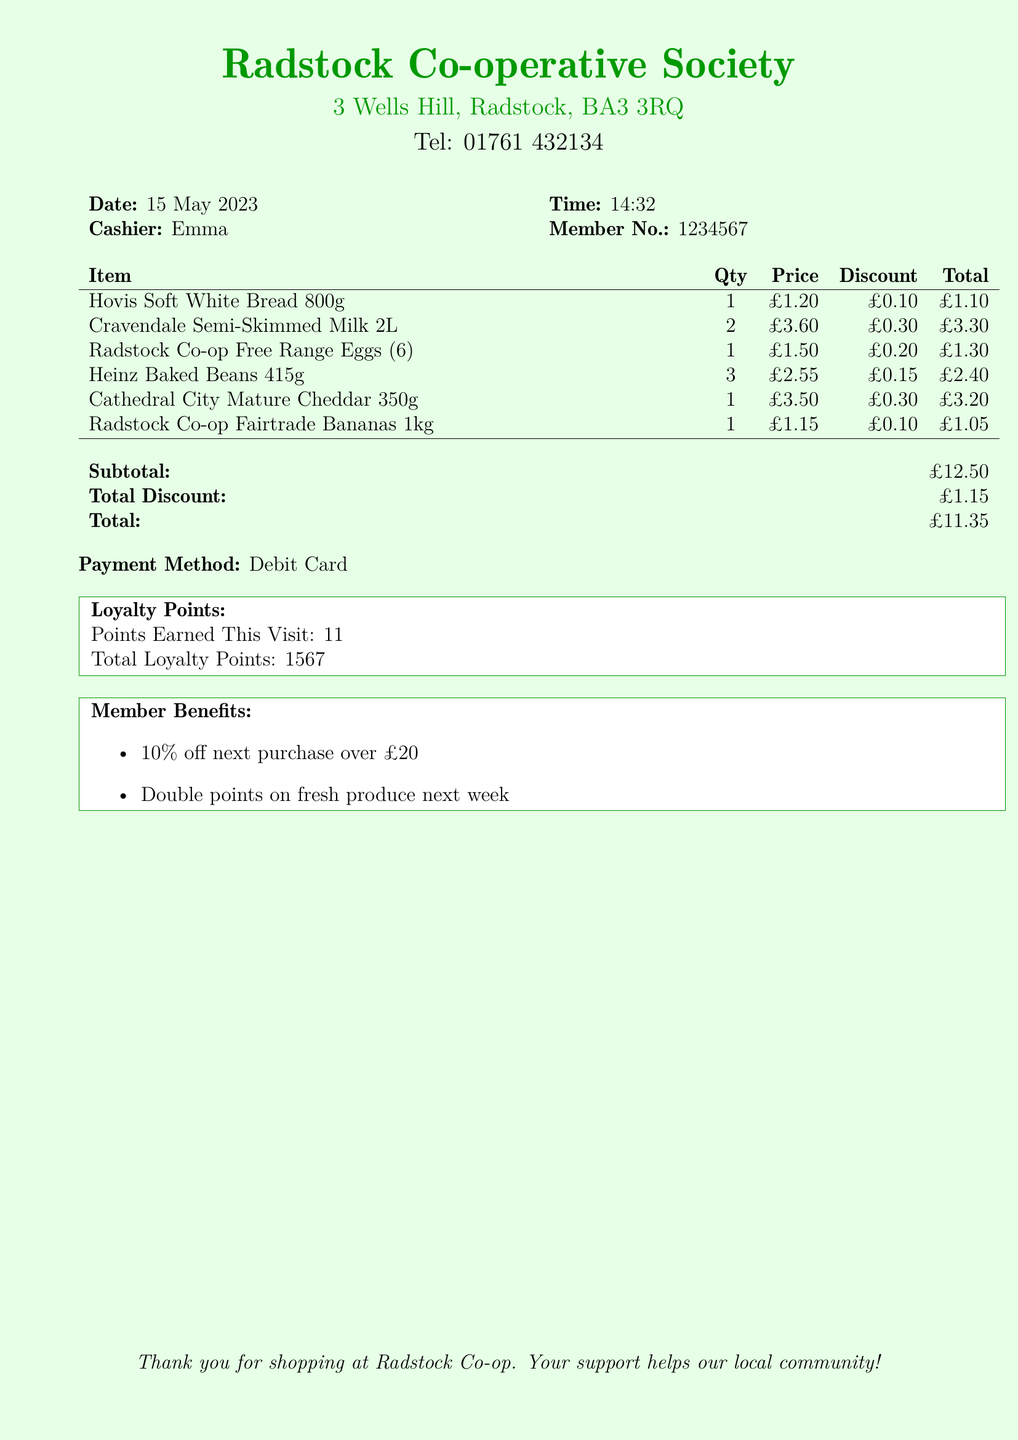what is the date of the purchase? The date of the purchase is provided in the document under the Date section.
Answer: 15 May 2023 who was the cashier? The name of the cashier is indicated next to the Cashier label in the document.
Answer: Emma how many loyalty points were earned in this visit? The loyalty points earned for this visit are listed in the Loyalty Points section of the document.
Answer: 11 what is the total amount spent? The total amount spent is calculated after applying discounts and is shown in the Total section of the document.
Answer: £11.35 how much was the total discount? The total discount amount is explicitly mentioned in the document under the Total Discount section.
Answer: £1.15 what is the subtotal before discounts? The subtotal before discounts can be found in the Subtotal section of the document.
Answer: £12.50 what are the member benefits listed? The member benefits are detailed in a list format in the Member Benefits section of the document.
Answer: 10% off next purchase over £20, Double points on fresh produce next week how many total loyalty points are there now? The total loyalty points accumulated by the member are provided in the Loyalty Points section.
Answer: 1567 what is the price of the Cravendale Semi-Skimmed Milk for one? The price per quantity is indicated in the price column next to the item in the document.
Answer: £1.80 